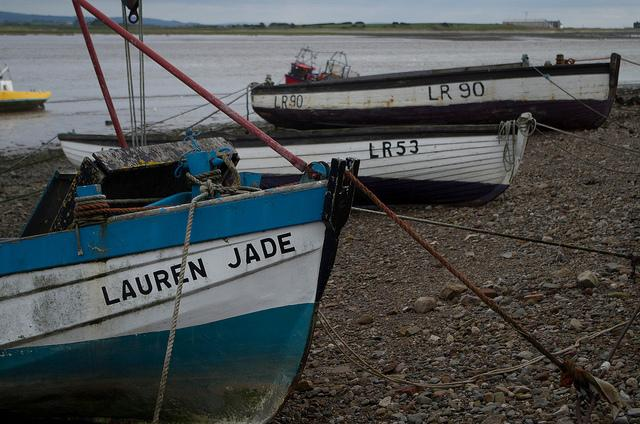What celebrity first name appears on the boat? Please explain your reasoning. lauren cohan. They have the same name 